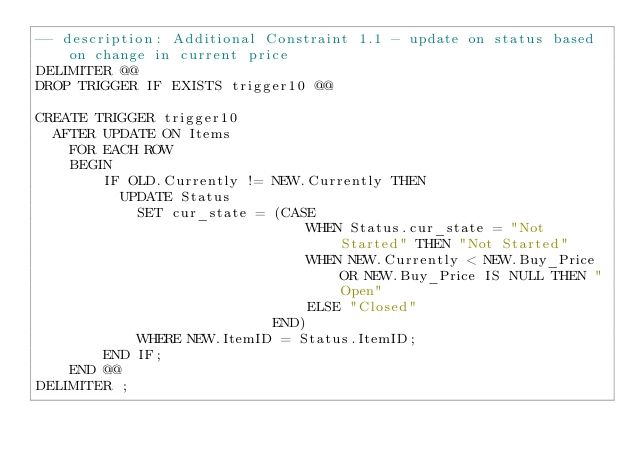Convert code to text. <code><loc_0><loc_0><loc_500><loc_500><_SQL_>-- description: Additional Constraint 1.1 - update on status based on change in current price
DELIMITER @@
DROP TRIGGER IF EXISTS trigger10 @@

CREATE TRIGGER trigger10
	AFTER UPDATE ON Items
    FOR EACH ROW 
    BEGIN
        IF OLD.Currently != NEW.Currently THEN
        	UPDATE Status 
            SET cur_state = (CASE
                                WHEN Status.cur_state = "Not Started" THEN "Not Started"
                                WHEN NEW.Currently < NEW.Buy_Price OR NEW.Buy_Price IS NULL THEN "Open"
                                ELSE "Closed"
                            END)
            WHERE NEW.ItemID = Status.ItemID;
        END IF;
    END @@
DELIMITER ;</code> 